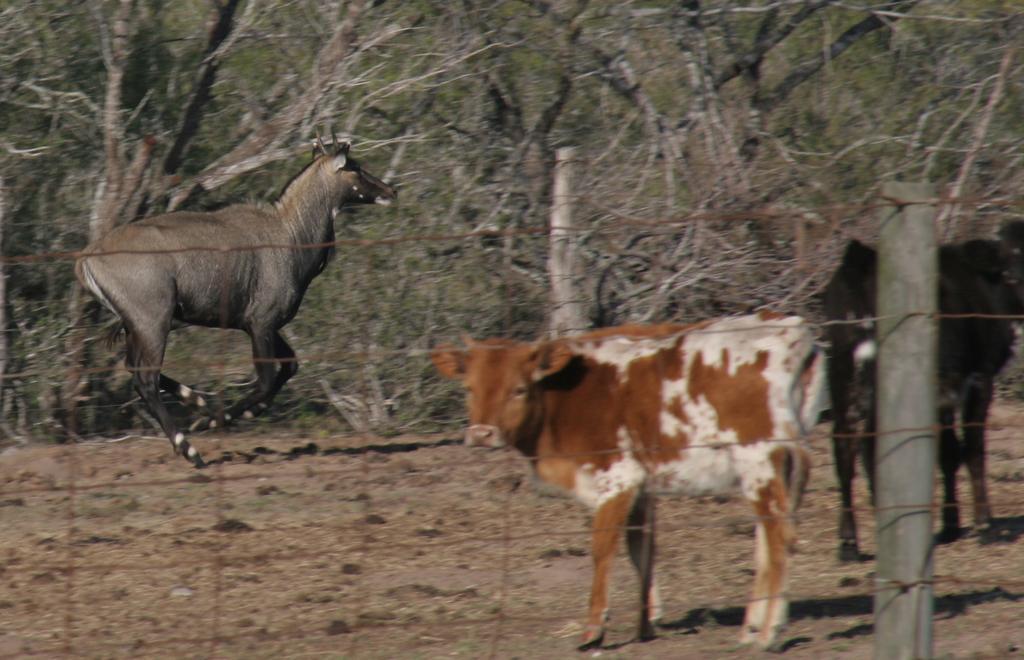Please provide a concise description of this image. In the foreground of this image, there is a cow and two animals are behind the fencing. In the background, there are trees. 